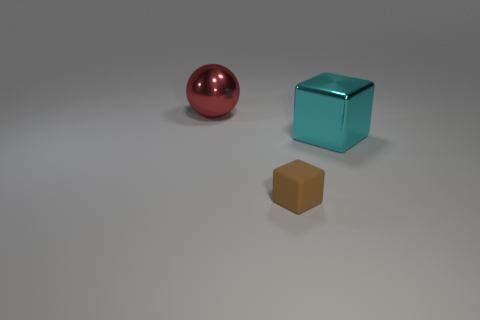Add 2 brown rubber balls. How many objects exist? 5 Subtract all spheres. How many objects are left? 2 Add 2 cyan metallic cubes. How many cyan metallic cubes are left? 3 Add 1 tiny shiny cylinders. How many tiny shiny cylinders exist? 1 Subtract 0 gray cubes. How many objects are left? 3 Subtract all large red objects. Subtract all rubber cubes. How many objects are left? 1 